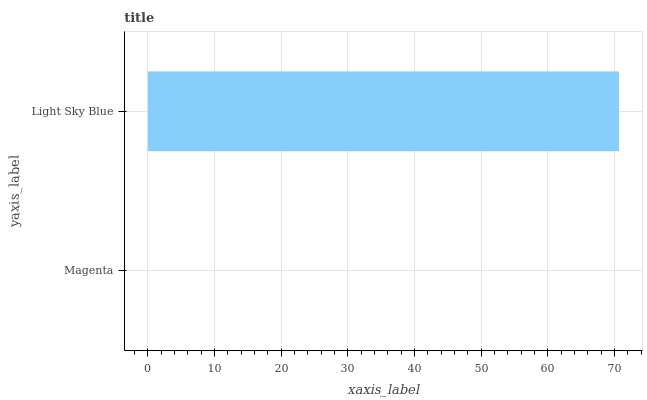Is Magenta the minimum?
Answer yes or no. Yes. Is Light Sky Blue the maximum?
Answer yes or no. Yes. Is Light Sky Blue the minimum?
Answer yes or no. No. Is Light Sky Blue greater than Magenta?
Answer yes or no. Yes. Is Magenta less than Light Sky Blue?
Answer yes or no. Yes. Is Magenta greater than Light Sky Blue?
Answer yes or no. No. Is Light Sky Blue less than Magenta?
Answer yes or no. No. Is Light Sky Blue the high median?
Answer yes or no. Yes. Is Magenta the low median?
Answer yes or no. Yes. Is Magenta the high median?
Answer yes or no. No. Is Light Sky Blue the low median?
Answer yes or no. No. 